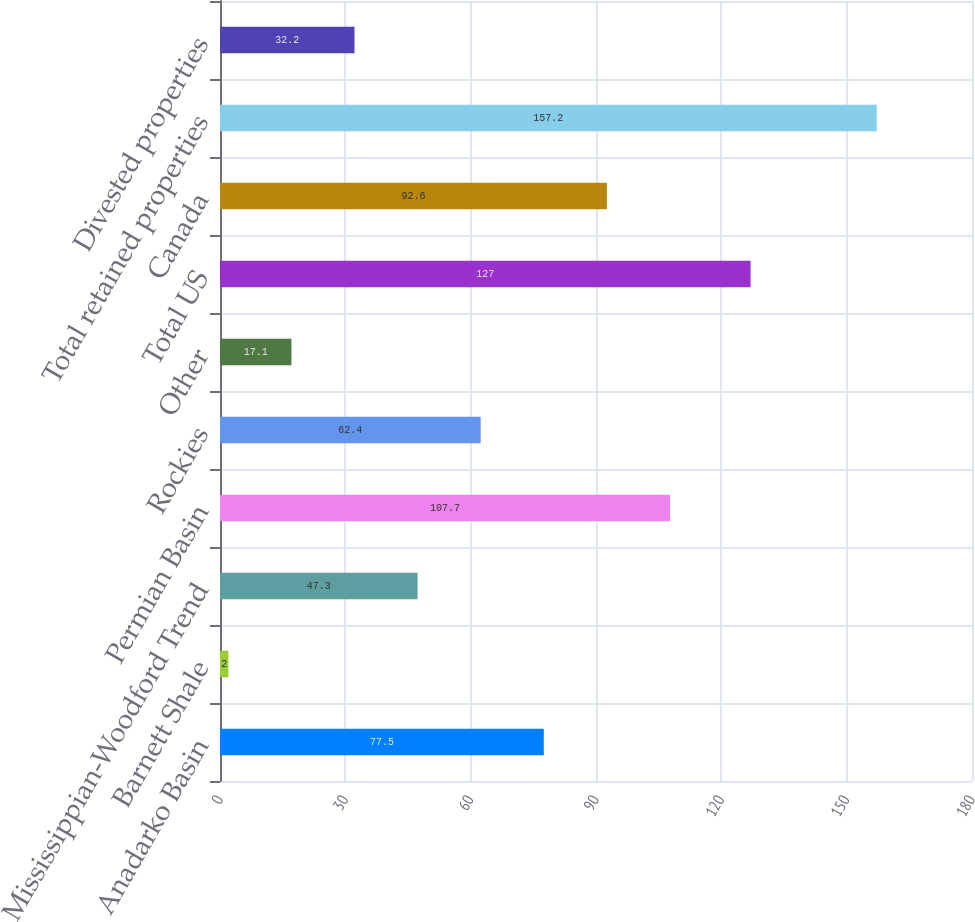Convert chart to OTSL. <chart><loc_0><loc_0><loc_500><loc_500><bar_chart><fcel>Anadarko Basin<fcel>Barnett Shale<fcel>Mississippian-Woodford Trend<fcel>Permian Basin<fcel>Rockies<fcel>Other<fcel>Total US<fcel>Canada<fcel>Total retained properties<fcel>Divested properties<nl><fcel>77.5<fcel>2<fcel>47.3<fcel>107.7<fcel>62.4<fcel>17.1<fcel>127<fcel>92.6<fcel>157.2<fcel>32.2<nl></chart> 